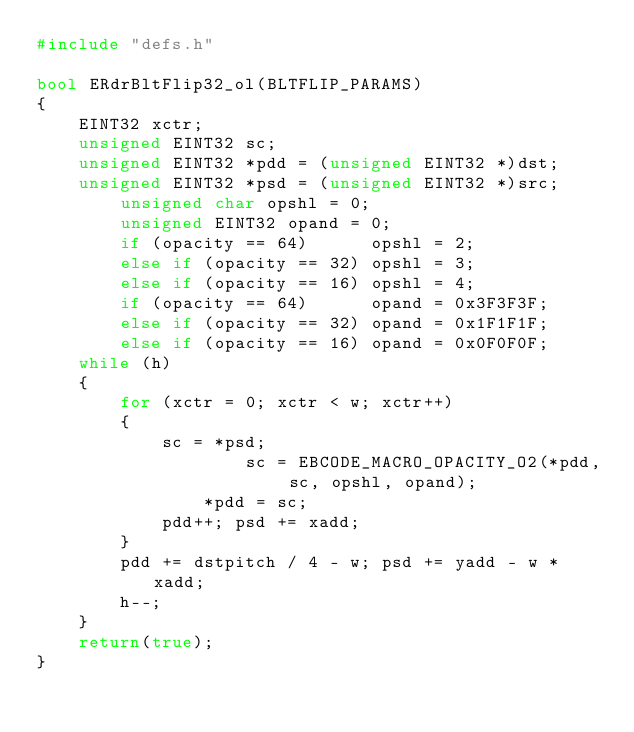Convert code to text. <code><loc_0><loc_0><loc_500><loc_500><_C++_>#include "defs.h"

bool ERdrBltFlip32_ol(BLTFLIP_PARAMS)
{
	EINT32 xctr;
	unsigned EINT32 sc;
	unsigned EINT32 *pdd = (unsigned EINT32 *)dst;
	unsigned EINT32 *psd = (unsigned EINT32 *)src;
		unsigned char opshl = 0;
		unsigned EINT32 opand = 0;
		if (opacity == 64)      opshl = 2;
		else if (opacity == 32) opshl = 3;
		else if (opacity == 16) opshl = 4;
		if (opacity == 64)      opand = 0x3F3F3F;
		else if (opacity == 32) opand = 0x1F1F1F;
		else if (opacity == 16) opand = 0x0F0F0F;
	while (h)
	{
		for (xctr = 0; xctr < w; xctr++)
		{
			sc = *psd;
					sc = EBCODE_MACRO_OPACITY_O2(*pdd, sc, opshl, opand);
				*pdd = sc;
			pdd++; psd += xadd;
		}
		pdd += dstpitch / 4 - w; psd += yadd - w * xadd;
		h--;
	}
	return(true);
}

</code> 